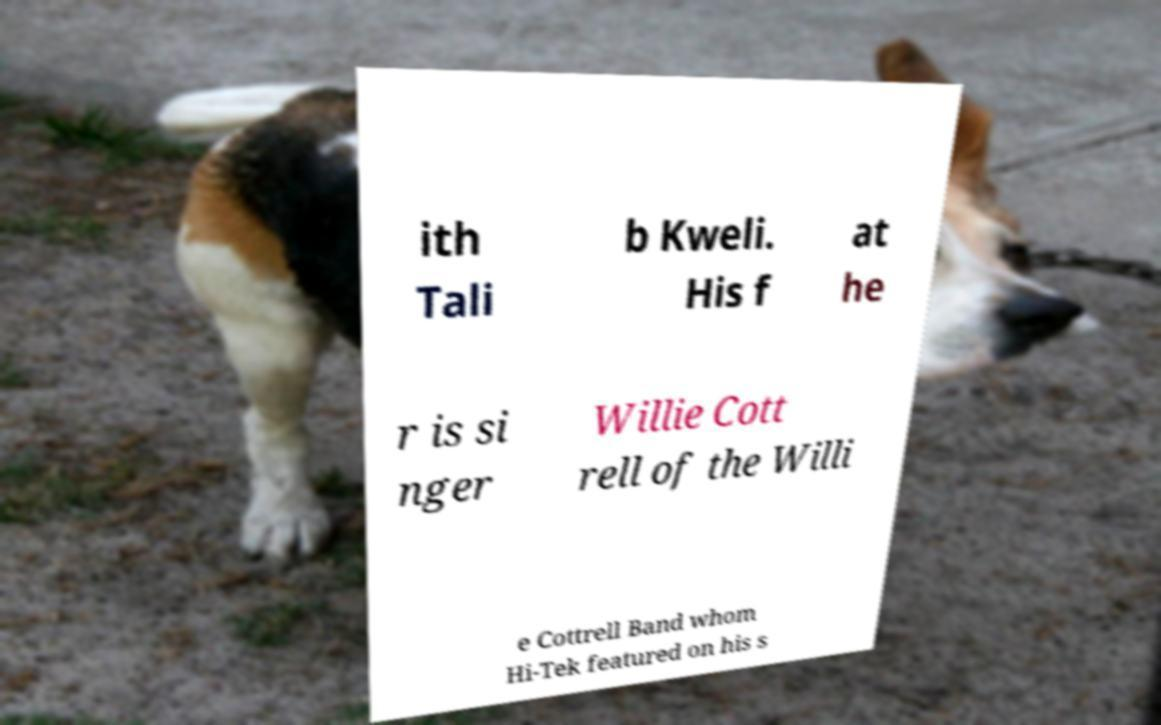There's text embedded in this image that I need extracted. Can you transcribe it verbatim? ith Tali b Kweli. His f at he r is si nger Willie Cott rell of the Willi e Cottrell Band whom Hi-Tek featured on his s 